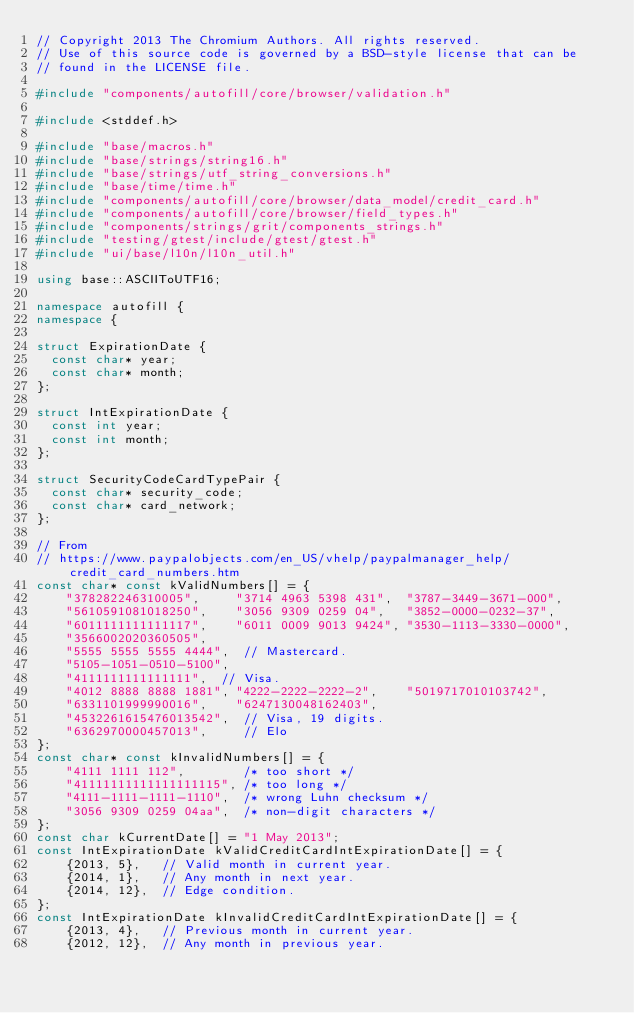Convert code to text. <code><loc_0><loc_0><loc_500><loc_500><_C++_>// Copyright 2013 The Chromium Authors. All rights reserved.
// Use of this source code is governed by a BSD-style license that can be
// found in the LICENSE file.

#include "components/autofill/core/browser/validation.h"

#include <stddef.h>

#include "base/macros.h"
#include "base/strings/string16.h"
#include "base/strings/utf_string_conversions.h"
#include "base/time/time.h"
#include "components/autofill/core/browser/data_model/credit_card.h"
#include "components/autofill/core/browser/field_types.h"
#include "components/strings/grit/components_strings.h"
#include "testing/gtest/include/gtest/gtest.h"
#include "ui/base/l10n/l10n_util.h"

using base::ASCIIToUTF16;

namespace autofill {
namespace {

struct ExpirationDate {
  const char* year;
  const char* month;
};

struct IntExpirationDate {
  const int year;
  const int month;
};

struct SecurityCodeCardTypePair {
  const char* security_code;
  const char* card_network;
};

// From
// https://www.paypalobjects.com/en_US/vhelp/paypalmanager_help/credit_card_numbers.htm
const char* const kValidNumbers[] = {
    "378282246310005",     "3714 4963 5398 431",  "3787-3449-3671-000",
    "5610591081018250",    "3056 9309 0259 04",   "3852-0000-0232-37",
    "6011111111111117",    "6011 0009 9013 9424", "3530-1113-3330-0000",
    "3566002020360505",
    "5555 5555 5555 4444",  // Mastercard.
    "5105-1051-0510-5100",
    "4111111111111111",  // Visa.
    "4012 8888 8888 1881", "4222-2222-2222-2",    "5019717010103742",
    "6331101999990016",    "6247130048162403",
    "4532261615476013542",  // Visa, 19 digits.
    "6362970000457013",     // Elo
};
const char* const kInvalidNumbers[] = {
    "4111 1111 112",        /* too short */
    "41111111111111111115", /* too long */
    "4111-1111-1111-1110",  /* wrong Luhn checksum */
    "3056 9309 0259 04aa",  /* non-digit characters */
};
const char kCurrentDate[] = "1 May 2013";
const IntExpirationDate kValidCreditCardIntExpirationDate[] = {
    {2013, 5},   // Valid month in current year.
    {2014, 1},   // Any month in next year.
    {2014, 12},  // Edge condition.
};
const IntExpirationDate kInvalidCreditCardIntExpirationDate[] = {
    {2013, 4},   // Previous month in current year.
    {2012, 12},  // Any month in previous year.</code> 